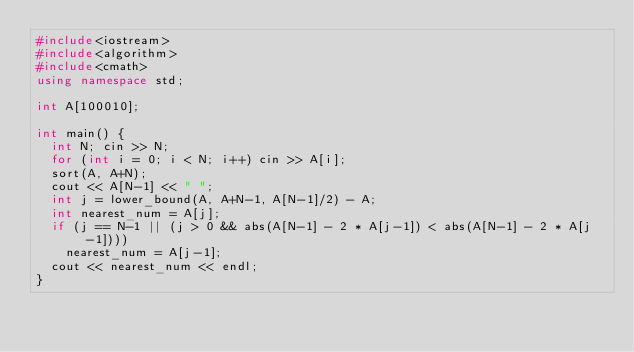Convert code to text. <code><loc_0><loc_0><loc_500><loc_500><_C++_>#include<iostream>
#include<algorithm>
#include<cmath>
using namespace std;

int A[100010];

int main() {
  int N; cin >> N;
  for (int i = 0; i < N; i++) cin >> A[i];
  sort(A, A+N);
  cout << A[N-1] << " ";
  int j = lower_bound(A, A+N-1, A[N-1]/2) - A;
  int nearest_num = A[j];
  if (j == N-1 || (j > 0 && abs(A[N-1] - 2 * A[j-1]) < abs(A[N-1] - 2 * A[j-1])))
    nearest_num = A[j-1];
  cout << nearest_num << endl;
}</code> 